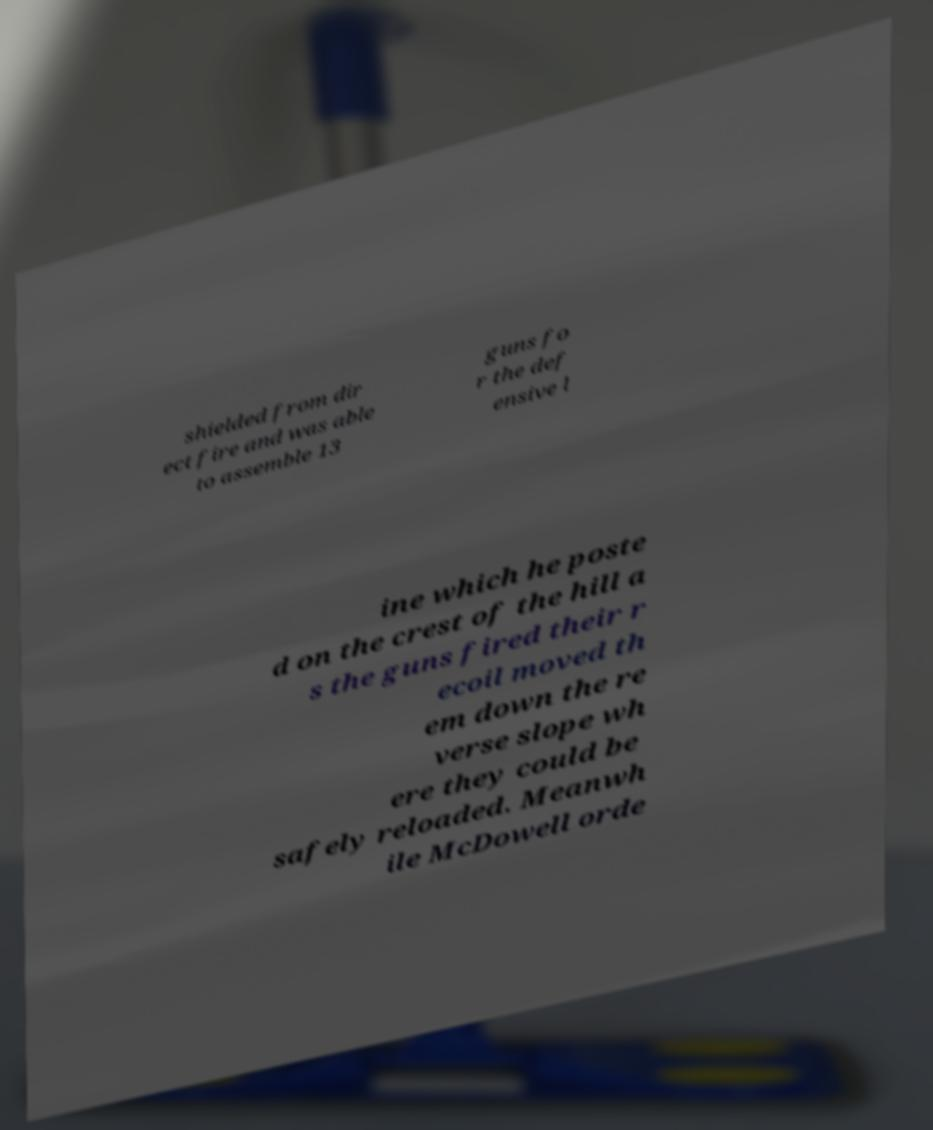Please read and relay the text visible in this image. What does it say? shielded from dir ect fire and was able to assemble 13 guns fo r the def ensive l ine which he poste d on the crest of the hill a s the guns fired their r ecoil moved th em down the re verse slope wh ere they could be safely reloaded. Meanwh ile McDowell orde 